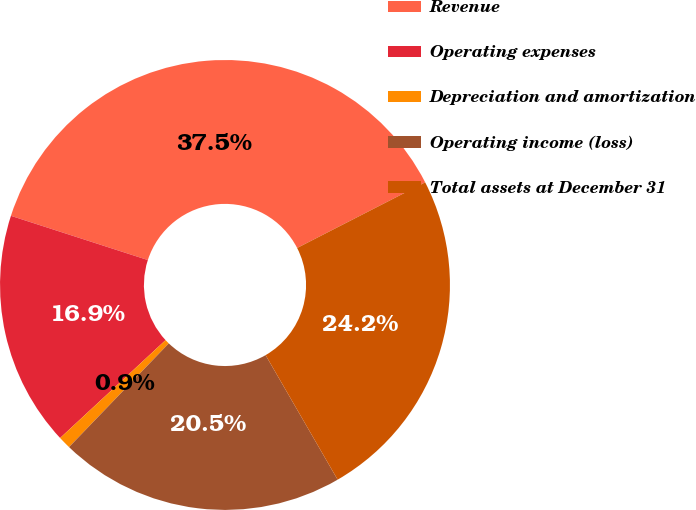<chart> <loc_0><loc_0><loc_500><loc_500><pie_chart><fcel>Revenue<fcel>Operating expenses<fcel>Depreciation and amortization<fcel>Operating income (loss)<fcel>Total assets at December 31<nl><fcel>37.49%<fcel>16.88%<fcel>0.9%<fcel>20.54%<fcel>24.19%<nl></chart> 